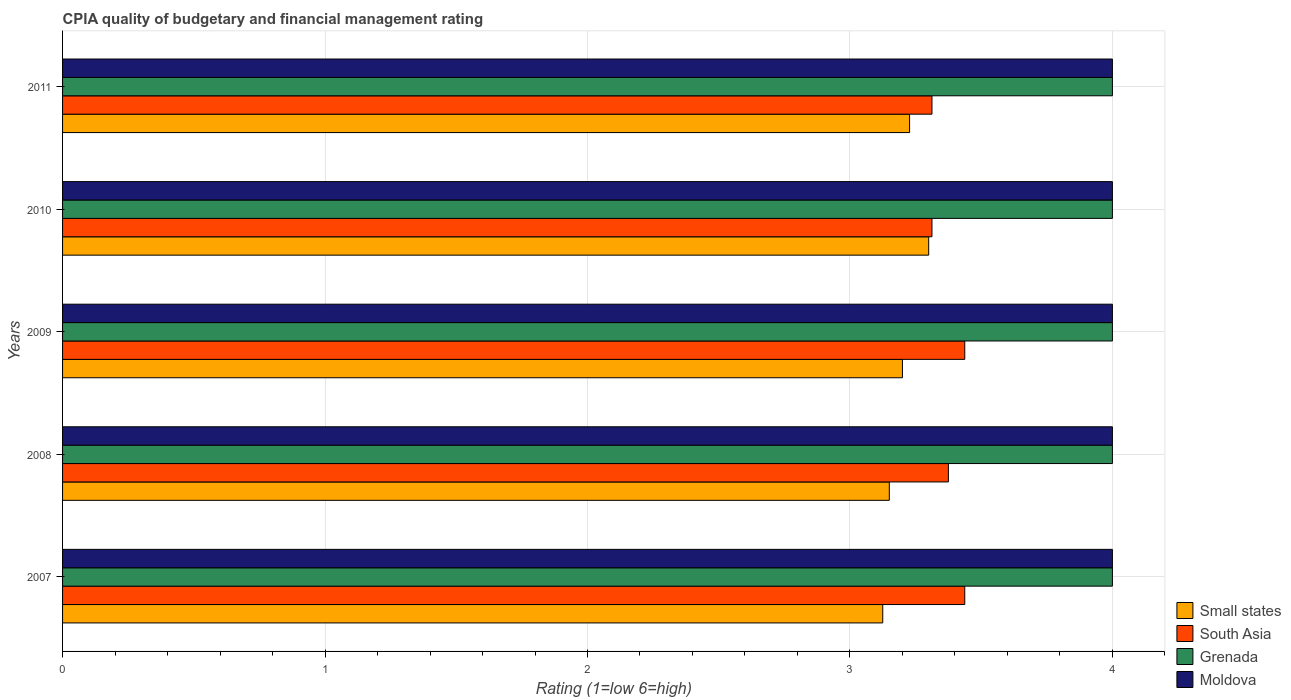Are the number of bars per tick equal to the number of legend labels?
Make the answer very short. Yes. How many bars are there on the 1st tick from the top?
Give a very brief answer. 4. In how many cases, is the number of bars for a given year not equal to the number of legend labels?
Provide a succinct answer. 0. What is the CPIA rating in South Asia in 2007?
Your response must be concise. 3.44. Across all years, what is the maximum CPIA rating in South Asia?
Offer a terse response. 3.44. In which year was the CPIA rating in Small states minimum?
Your answer should be very brief. 2007. What is the difference between the CPIA rating in South Asia in 2008 and that in 2009?
Your response must be concise. -0.06. What is the difference between the CPIA rating in South Asia in 2009 and the CPIA rating in Grenada in 2007?
Provide a succinct answer. -0.56. In the year 2009, what is the difference between the CPIA rating in Moldova and CPIA rating in Small states?
Your response must be concise. 0.8. Is the difference between the CPIA rating in Moldova in 2010 and 2011 greater than the difference between the CPIA rating in Small states in 2010 and 2011?
Make the answer very short. No. What is the difference between the highest and the second highest CPIA rating in Small states?
Your answer should be very brief. 0.07. What is the difference between the highest and the lowest CPIA rating in Grenada?
Your response must be concise. 0. What does the 3rd bar from the top in 2008 represents?
Make the answer very short. South Asia. What does the 4th bar from the bottom in 2009 represents?
Your answer should be very brief. Moldova. Is it the case that in every year, the sum of the CPIA rating in Moldova and CPIA rating in Small states is greater than the CPIA rating in South Asia?
Ensure brevity in your answer.  Yes. How many bars are there?
Provide a short and direct response. 20. Are all the bars in the graph horizontal?
Make the answer very short. Yes. How many years are there in the graph?
Offer a terse response. 5. What is the difference between two consecutive major ticks on the X-axis?
Provide a short and direct response. 1. Are the values on the major ticks of X-axis written in scientific E-notation?
Your answer should be very brief. No. Does the graph contain any zero values?
Your answer should be very brief. No. Where does the legend appear in the graph?
Your answer should be very brief. Bottom right. How many legend labels are there?
Ensure brevity in your answer.  4. How are the legend labels stacked?
Provide a succinct answer. Vertical. What is the title of the graph?
Your answer should be very brief. CPIA quality of budgetary and financial management rating. Does "Angola" appear as one of the legend labels in the graph?
Your response must be concise. No. What is the label or title of the X-axis?
Your response must be concise. Rating (1=low 6=high). What is the Rating (1=low 6=high) of Small states in 2007?
Give a very brief answer. 3.12. What is the Rating (1=low 6=high) of South Asia in 2007?
Your response must be concise. 3.44. What is the Rating (1=low 6=high) of Grenada in 2007?
Offer a terse response. 4. What is the Rating (1=low 6=high) in Moldova in 2007?
Your response must be concise. 4. What is the Rating (1=low 6=high) of Small states in 2008?
Give a very brief answer. 3.15. What is the Rating (1=low 6=high) in South Asia in 2008?
Your answer should be compact. 3.38. What is the Rating (1=low 6=high) in Grenada in 2008?
Your response must be concise. 4. What is the Rating (1=low 6=high) in Moldova in 2008?
Your response must be concise. 4. What is the Rating (1=low 6=high) of Small states in 2009?
Give a very brief answer. 3.2. What is the Rating (1=low 6=high) in South Asia in 2009?
Offer a terse response. 3.44. What is the Rating (1=low 6=high) of Grenada in 2009?
Your answer should be compact. 4. What is the Rating (1=low 6=high) of Moldova in 2009?
Provide a short and direct response. 4. What is the Rating (1=low 6=high) in South Asia in 2010?
Your answer should be very brief. 3.31. What is the Rating (1=low 6=high) of Moldova in 2010?
Ensure brevity in your answer.  4. What is the Rating (1=low 6=high) of Small states in 2011?
Your answer should be compact. 3.23. What is the Rating (1=low 6=high) of South Asia in 2011?
Give a very brief answer. 3.31. Across all years, what is the maximum Rating (1=low 6=high) in Small states?
Your answer should be compact. 3.3. Across all years, what is the maximum Rating (1=low 6=high) of South Asia?
Keep it short and to the point. 3.44. Across all years, what is the maximum Rating (1=low 6=high) in Grenada?
Provide a short and direct response. 4. Across all years, what is the maximum Rating (1=low 6=high) of Moldova?
Offer a terse response. 4. Across all years, what is the minimum Rating (1=low 6=high) of Small states?
Offer a terse response. 3.12. Across all years, what is the minimum Rating (1=low 6=high) in South Asia?
Provide a short and direct response. 3.31. Across all years, what is the minimum Rating (1=low 6=high) of Grenada?
Provide a succinct answer. 4. What is the total Rating (1=low 6=high) of Small states in the graph?
Offer a very short reply. 16. What is the total Rating (1=low 6=high) in South Asia in the graph?
Provide a short and direct response. 16.88. What is the total Rating (1=low 6=high) in Moldova in the graph?
Your answer should be compact. 20. What is the difference between the Rating (1=low 6=high) in Small states in 2007 and that in 2008?
Offer a very short reply. -0.03. What is the difference between the Rating (1=low 6=high) of South Asia in 2007 and that in 2008?
Your response must be concise. 0.06. What is the difference between the Rating (1=low 6=high) in Moldova in 2007 and that in 2008?
Your response must be concise. 0. What is the difference between the Rating (1=low 6=high) of Small states in 2007 and that in 2009?
Make the answer very short. -0.07. What is the difference between the Rating (1=low 6=high) in Moldova in 2007 and that in 2009?
Offer a terse response. 0. What is the difference between the Rating (1=low 6=high) of Small states in 2007 and that in 2010?
Your response must be concise. -0.17. What is the difference between the Rating (1=low 6=high) of South Asia in 2007 and that in 2010?
Give a very brief answer. 0.12. What is the difference between the Rating (1=low 6=high) in Moldova in 2007 and that in 2010?
Offer a very short reply. 0. What is the difference between the Rating (1=low 6=high) in Small states in 2007 and that in 2011?
Ensure brevity in your answer.  -0.1. What is the difference between the Rating (1=low 6=high) in Grenada in 2007 and that in 2011?
Make the answer very short. 0. What is the difference between the Rating (1=low 6=high) in Small states in 2008 and that in 2009?
Offer a very short reply. -0.05. What is the difference between the Rating (1=low 6=high) of South Asia in 2008 and that in 2009?
Ensure brevity in your answer.  -0.06. What is the difference between the Rating (1=low 6=high) of Grenada in 2008 and that in 2009?
Ensure brevity in your answer.  0. What is the difference between the Rating (1=low 6=high) in Small states in 2008 and that in 2010?
Provide a short and direct response. -0.15. What is the difference between the Rating (1=low 6=high) in South Asia in 2008 and that in 2010?
Offer a very short reply. 0.06. What is the difference between the Rating (1=low 6=high) of Grenada in 2008 and that in 2010?
Provide a short and direct response. 0. What is the difference between the Rating (1=low 6=high) of Moldova in 2008 and that in 2010?
Offer a terse response. 0. What is the difference between the Rating (1=low 6=high) of Small states in 2008 and that in 2011?
Ensure brevity in your answer.  -0.08. What is the difference between the Rating (1=low 6=high) of South Asia in 2008 and that in 2011?
Offer a very short reply. 0.06. What is the difference between the Rating (1=low 6=high) in Moldova in 2008 and that in 2011?
Keep it short and to the point. 0. What is the difference between the Rating (1=low 6=high) of Small states in 2009 and that in 2010?
Offer a very short reply. -0.1. What is the difference between the Rating (1=low 6=high) of South Asia in 2009 and that in 2010?
Your answer should be compact. 0.12. What is the difference between the Rating (1=low 6=high) of Grenada in 2009 and that in 2010?
Keep it short and to the point. 0. What is the difference between the Rating (1=low 6=high) in Moldova in 2009 and that in 2010?
Provide a short and direct response. 0. What is the difference between the Rating (1=low 6=high) of Small states in 2009 and that in 2011?
Provide a succinct answer. -0.03. What is the difference between the Rating (1=low 6=high) of South Asia in 2009 and that in 2011?
Give a very brief answer. 0.12. What is the difference between the Rating (1=low 6=high) of Small states in 2010 and that in 2011?
Ensure brevity in your answer.  0.07. What is the difference between the Rating (1=low 6=high) in South Asia in 2010 and that in 2011?
Offer a very short reply. 0. What is the difference between the Rating (1=low 6=high) in Grenada in 2010 and that in 2011?
Your answer should be very brief. 0. What is the difference between the Rating (1=low 6=high) of Small states in 2007 and the Rating (1=low 6=high) of South Asia in 2008?
Your answer should be compact. -0.25. What is the difference between the Rating (1=low 6=high) of Small states in 2007 and the Rating (1=low 6=high) of Grenada in 2008?
Make the answer very short. -0.88. What is the difference between the Rating (1=low 6=high) in Small states in 2007 and the Rating (1=low 6=high) in Moldova in 2008?
Your answer should be very brief. -0.88. What is the difference between the Rating (1=low 6=high) in South Asia in 2007 and the Rating (1=low 6=high) in Grenada in 2008?
Ensure brevity in your answer.  -0.56. What is the difference between the Rating (1=low 6=high) in South Asia in 2007 and the Rating (1=low 6=high) in Moldova in 2008?
Provide a short and direct response. -0.56. What is the difference between the Rating (1=low 6=high) of Grenada in 2007 and the Rating (1=low 6=high) of Moldova in 2008?
Your answer should be compact. 0. What is the difference between the Rating (1=low 6=high) in Small states in 2007 and the Rating (1=low 6=high) in South Asia in 2009?
Your response must be concise. -0.31. What is the difference between the Rating (1=low 6=high) in Small states in 2007 and the Rating (1=low 6=high) in Grenada in 2009?
Keep it short and to the point. -0.88. What is the difference between the Rating (1=low 6=high) of Small states in 2007 and the Rating (1=low 6=high) of Moldova in 2009?
Your answer should be very brief. -0.88. What is the difference between the Rating (1=low 6=high) in South Asia in 2007 and the Rating (1=low 6=high) in Grenada in 2009?
Offer a very short reply. -0.56. What is the difference between the Rating (1=low 6=high) of South Asia in 2007 and the Rating (1=low 6=high) of Moldova in 2009?
Ensure brevity in your answer.  -0.56. What is the difference between the Rating (1=low 6=high) of Small states in 2007 and the Rating (1=low 6=high) of South Asia in 2010?
Provide a short and direct response. -0.19. What is the difference between the Rating (1=low 6=high) in Small states in 2007 and the Rating (1=low 6=high) in Grenada in 2010?
Offer a terse response. -0.88. What is the difference between the Rating (1=low 6=high) of Small states in 2007 and the Rating (1=low 6=high) of Moldova in 2010?
Keep it short and to the point. -0.88. What is the difference between the Rating (1=low 6=high) of South Asia in 2007 and the Rating (1=low 6=high) of Grenada in 2010?
Your response must be concise. -0.56. What is the difference between the Rating (1=low 6=high) of South Asia in 2007 and the Rating (1=low 6=high) of Moldova in 2010?
Offer a terse response. -0.56. What is the difference between the Rating (1=low 6=high) of Small states in 2007 and the Rating (1=low 6=high) of South Asia in 2011?
Offer a very short reply. -0.19. What is the difference between the Rating (1=low 6=high) in Small states in 2007 and the Rating (1=low 6=high) in Grenada in 2011?
Offer a terse response. -0.88. What is the difference between the Rating (1=low 6=high) of Small states in 2007 and the Rating (1=low 6=high) of Moldova in 2011?
Offer a terse response. -0.88. What is the difference between the Rating (1=low 6=high) in South Asia in 2007 and the Rating (1=low 6=high) in Grenada in 2011?
Ensure brevity in your answer.  -0.56. What is the difference between the Rating (1=low 6=high) in South Asia in 2007 and the Rating (1=low 6=high) in Moldova in 2011?
Keep it short and to the point. -0.56. What is the difference between the Rating (1=low 6=high) in Grenada in 2007 and the Rating (1=low 6=high) in Moldova in 2011?
Make the answer very short. 0. What is the difference between the Rating (1=low 6=high) of Small states in 2008 and the Rating (1=low 6=high) of South Asia in 2009?
Your response must be concise. -0.29. What is the difference between the Rating (1=low 6=high) of Small states in 2008 and the Rating (1=low 6=high) of Grenada in 2009?
Your response must be concise. -0.85. What is the difference between the Rating (1=low 6=high) of Small states in 2008 and the Rating (1=low 6=high) of Moldova in 2009?
Give a very brief answer. -0.85. What is the difference between the Rating (1=low 6=high) in South Asia in 2008 and the Rating (1=low 6=high) in Grenada in 2009?
Provide a succinct answer. -0.62. What is the difference between the Rating (1=low 6=high) of South Asia in 2008 and the Rating (1=low 6=high) of Moldova in 2009?
Keep it short and to the point. -0.62. What is the difference between the Rating (1=low 6=high) in Grenada in 2008 and the Rating (1=low 6=high) in Moldova in 2009?
Offer a terse response. 0. What is the difference between the Rating (1=low 6=high) of Small states in 2008 and the Rating (1=low 6=high) of South Asia in 2010?
Offer a terse response. -0.16. What is the difference between the Rating (1=low 6=high) in Small states in 2008 and the Rating (1=low 6=high) in Grenada in 2010?
Offer a terse response. -0.85. What is the difference between the Rating (1=low 6=high) of Small states in 2008 and the Rating (1=low 6=high) of Moldova in 2010?
Your answer should be compact. -0.85. What is the difference between the Rating (1=low 6=high) of South Asia in 2008 and the Rating (1=low 6=high) of Grenada in 2010?
Make the answer very short. -0.62. What is the difference between the Rating (1=low 6=high) of South Asia in 2008 and the Rating (1=low 6=high) of Moldova in 2010?
Provide a succinct answer. -0.62. What is the difference between the Rating (1=low 6=high) in Grenada in 2008 and the Rating (1=low 6=high) in Moldova in 2010?
Ensure brevity in your answer.  0. What is the difference between the Rating (1=low 6=high) in Small states in 2008 and the Rating (1=low 6=high) in South Asia in 2011?
Your response must be concise. -0.16. What is the difference between the Rating (1=low 6=high) in Small states in 2008 and the Rating (1=low 6=high) in Grenada in 2011?
Your answer should be compact. -0.85. What is the difference between the Rating (1=low 6=high) of Small states in 2008 and the Rating (1=low 6=high) of Moldova in 2011?
Offer a very short reply. -0.85. What is the difference between the Rating (1=low 6=high) of South Asia in 2008 and the Rating (1=low 6=high) of Grenada in 2011?
Your answer should be compact. -0.62. What is the difference between the Rating (1=low 6=high) in South Asia in 2008 and the Rating (1=low 6=high) in Moldova in 2011?
Give a very brief answer. -0.62. What is the difference between the Rating (1=low 6=high) in Grenada in 2008 and the Rating (1=low 6=high) in Moldova in 2011?
Your answer should be compact. 0. What is the difference between the Rating (1=low 6=high) of Small states in 2009 and the Rating (1=low 6=high) of South Asia in 2010?
Offer a terse response. -0.11. What is the difference between the Rating (1=low 6=high) in Small states in 2009 and the Rating (1=low 6=high) in Moldova in 2010?
Offer a terse response. -0.8. What is the difference between the Rating (1=low 6=high) in South Asia in 2009 and the Rating (1=low 6=high) in Grenada in 2010?
Ensure brevity in your answer.  -0.56. What is the difference between the Rating (1=low 6=high) in South Asia in 2009 and the Rating (1=low 6=high) in Moldova in 2010?
Keep it short and to the point. -0.56. What is the difference between the Rating (1=low 6=high) of Small states in 2009 and the Rating (1=low 6=high) of South Asia in 2011?
Ensure brevity in your answer.  -0.11. What is the difference between the Rating (1=low 6=high) of Small states in 2009 and the Rating (1=low 6=high) of Grenada in 2011?
Your answer should be compact. -0.8. What is the difference between the Rating (1=low 6=high) of Small states in 2009 and the Rating (1=low 6=high) of Moldova in 2011?
Give a very brief answer. -0.8. What is the difference between the Rating (1=low 6=high) in South Asia in 2009 and the Rating (1=low 6=high) in Grenada in 2011?
Offer a terse response. -0.56. What is the difference between the Rating (1=low 6=high) of South Asia in 2009 and the Rating (1=low 6=high) of Moldova in 2011?
Provide a short and direct response. -0.56. What is the difference between the Rating (1=low 6=high) of Small states in 2010 and the Rating (1=low 6=high) of South Asia in 2011?
Your response must be concise. -0.01. What is the difference between the Rating (1=low 6=high) of South Asia in 2010 and the Rating (1=low 6=high) of Grenada in 2011?
Your answer should be compact. -0.69. What is the difference between the Rating (1=low 6=high) in South Asia in 2010 and the Rating (1=low 6=high) in Moldova in 2011?
Give a very brief answer. -0.69. What is the average Rating (1=low 6=high) of Small states per year?
Offer a very short reply. 3.2. What is the average Rating (1=low 6=high) in South Asia per year?
Give a very brief answer. 3.38. In the year 2007, what is the difference between the Rating (1=low 6=high) of Small states and Rating (1=low 6=high) of South Asia?
Give a very brief answer. -0.31. In the year 2007, what is the difference between the Rating (1=low 6=high) of Small states and Rating (1=low 6=high) of Grenada?
Your answer should be very brief. -0.88. In the year 2007, what is the difference between the Rating (1=low 6=high) in Small states and Rating (1=low 6=high) in Moldova?
Offer a very short reply. -0.88. In the year 2007, what is the difference between the Rating (1=low 6=high) of South Asia and Rating (1=low 6=high) of Grenada?
Provide a succinct answer. -0.56. In the year 2007, what is the difference between the Rating (1=low 6=high) in South Asia and Rating (1=low 6=high) in Moldova?
Your answer should be compact. -0.56. In the year 2007, what is the difference between the Rating (1=low 6=high) of Grenada and Rating (1=low 6=high) of Moldova?
Give a very brief answer. 0. In the year 2008, what is the difference between the Rating (1=low 6=high) of Small states and Rating (1=low 6=high) of South Asia?
Your answer should be compact. -0.23. In the year 2008, what is the difference between the Rating (1=low 6=high) in Small states and Rating (1=low 6=high) in Grenada?
Keep it short and to the point. -0.85. In the year 2008, what is the difference between the Rating (1=low 6=high) in Small states and Rating (1=low 6=high) in Moldova?
Your answer should be very brief. -0.85. In the year 2008, what is the difference between the Rating (1=low 6=high) of South Asia and Rating (1=low 6=high) of Grenada?
Your response must be concise. -0.62. In the year 2008, what is the difference between the Rating (1=low 6=high) of South Asia and Rating (1=low 6=high) of Moldova?
Make the answer very short. -0.62. In the year 2009, what is the difference between the Rating (1=low 6=high) in Small states and Rating (1=low 6=high) in South Asia?
Ensure brevity in your answer.  -0.24. In the year 2009, what is the difference between the Rating (1=low 6=high) in Small states and Rating (1=low 6=high) in Moldova?
Offer a very short reply. -0.8. In the year 2009, what is the difference between the Rating (1=low 6=high) of South Asia and Rating (1=low 6=high) of Grenada?
Keep it short and to the point. -0.56. In the year 2009, what is the difference between the Rating (1=low 6=high) in South Asia and Rating (1=low 6=high) in Moldova?
Your answer should be compact. -0.56. In the year 2009, what is the difference between the Rating (1=low 6=high) in Grenada and Rating (1=low 6=high) in Moldova?
Your answer should be very brief. 0. In the year 2010, what is the difference between the Rating (1=low 6=high) in Small states and Rating (1=low 6=high) in South Asia?
Provide a short and direct response. -0.01. In the year 2010, what is the difference between the Rating (1=low 6=high) of Small states and Rating (1=low 6=high) of Grenada?
Provide a short and direct response. -0.7. In the year 2010, what is the difference between the Rating (1=low 6=high) of South Asia and Rating (1=low 6=high) of Grenada?
Make the answer very short. -0.69. In the year 2010, what is the difference between the Rating (1=low 6=high) in South Asia and Rating (1=low 6=high) in Moldova?
Give a very brief answer. -0.69. In the year 2010, what is the difference between the Rating (1=low 6=high) in Grenada and Rating (1=low 6=high) in Moldova?
Your response must be concise. 0. In the year 2011, what is the difference between the Rating (1=low 6=high) in Small states and Rating (1=low 6=high) in South Asia?
Your answer should be very brief. -0.09. In the year 2011, what is the difference between the Rating (1=low 6=high) in Small states and Rating (1=low 6=high) in Grenada?
Your answer should be compact. -0.77. In the year 2011, what is the difference between the Rating (1=low 6=high) of Small states and Rating (1=low 6=high) of Moldova?
Make the answer very short. -0.77. In the year 2011, what is the difference between the Rating (1=low 6=high) of South Asia and Rating (1=low 6=high) of Grenada?
Make the answer very short. -0.69. In the year 2011, what is the difference between the Rating (1=low 6=high) of South Asia and Rating (1=low 6=high) of Moldova?
Make the answer very short. -0.69. What is the ratio of the Rating (1=low 6=high) of Small states in 2007 to that in 2008?
Your answer should be compact. 0.99. What is the ratio of the Rating (1=low 6=high) of South Asia in 2007 to that in 2008?
Your answer should be compact. 1.02. What is the ratio of the Rating (1=low 6=high) in Moldova in 2007 to that in 2008?
Your response must be concise. 1. What is the ratio of the Rating (1=low 6=high) in Small states in 2007 to that in 2009?
Keep it short and to the point. 0.98. What is the ratio of the Rating (1=low 6=high) of Grenada in 2007 to that in 2009?
Your response must be concise. 1. What is the ratio of the Rating (1=low 6=high) of Small states in 2007 to that in 2010?
Offer a very short reply. 0.95. What is the ratio of the Rating (1=low 6=high) of South Asia in 2007 to that in 2010?
Offer a terse response. 1.04. What is the ratio of the Rating (1=low 6=high) in Small states in 2007 to that in 2011?
Your answer should be very brief. 0.97. What is the ratio of the Rating (1=low 6=high) in South Asia in 2007 to that in 2011?
Offer a very short reply. 1.04. What is the ratio of the Rating (1=low 6=high) of Small states in 2008 to that in 2009?
Your response must be concise. 0.98. What is the ratio of the Rating (1=low 6=high) of South Asia in 2008 to that in 2009?
Offer a very short reply. 0.98. What is the ratio of the Rating (1=low 6=high) in Grenada in 2008 to that in 2009?
Give a very brief answer. 1. What is the ratio of the Rating (1=low 6=high) in Small states in 2008 to that in 2010?
Provide a succinct answer. 0.95. What is the ratio of the Rating (1=low 6=high) in South Asia in 2008 to that in 2010?
Offer a terse response. 1.02. What is the ratio of the Rating (1=low 6=high) of Grenada in 2008 to that in 2010?
Make the answer very short. 1. What is the ratio of the Rating (1=low 6=high) in Moldova in 2008 to that in 2010?
Provide a short and direct response. 1. What is the ratio of the Rating (1=low 6=high) in Small states in 2008 to that in 2011?
Offer a terse response. 0.98. What is the ratio of the Rating (1=low 6=high) in South Asia in 2008 to that in 2011?
Your answer should be very brief. 1.02. What is the ratio of the Rating (1=low 6=high) of Grenada in 2008 to that in 2011?
Your answer should be very brief. 1. What is the ratio of the Rating (1=low 6=high) in Small states in 2009 to that in 2010?
Give a very brief answer. 0.97. What is the ratio of the Rating (1=low 6=high) of South Asia in 2009 to that in 2010?
Give a very brief answer. 1.04. What is the ratio of the Rating (1=low 6=high) in Moldova in 2009 to that in 2010?
Give a very brief answer. 1. What is the ratio of the Rating (1=low 6=high) of South Asia in 2009 to that in 2011?
Give a very brief answer. 1.04. What is the ratio of the Rating (1=low 6=high) in Moldova in 2009 to that in 2011?
Your answer should be compact. 1. What is the ratio of the Rating (1=low 6=high) of Small states in 2010 to that in 2011?
Provide a succinct answer. 1.02. What is the ratio of the Rating (1=low 6=high) of South Asia in 2010 to that in 2011?
Keep it short and to the point. 1. What is the difference between the highest and the second highest Rating (1=low 6=high) in Small states?
Offer a very short reply. 0.07. What is the difference between the highest and the lowest Rating (1=low 6=high) in Small states?
Your answer should be very brief. 0.17. What is the difference between the highest and the lowest Rating (1=low 6=high) in Moldova?
Keep it short and to the point. 0. 